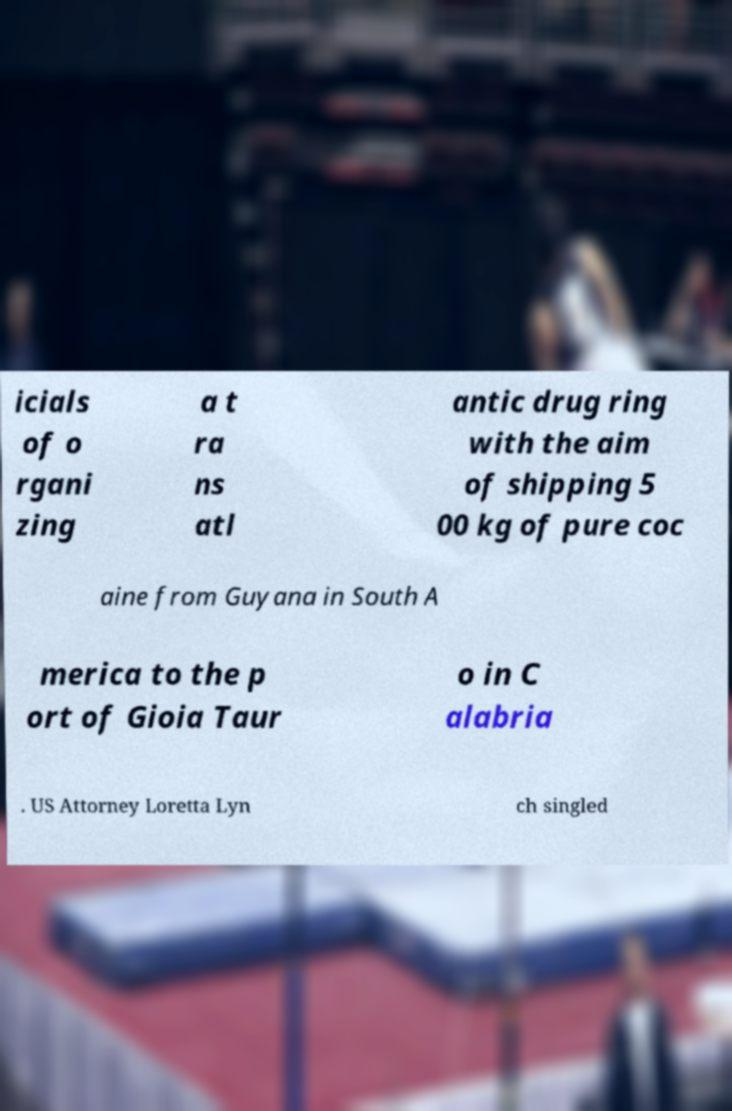I need the written content from this picture converted into text. Can you do that? icials of o rgani zing a t ra ns atl antic drug ring with the aim of shipping 5 00 kg of pure coc aine from Guyana in South A merica to the p ort of Gioia Taur o in C alabria . US Attorney Loretta Lyn ch singled 